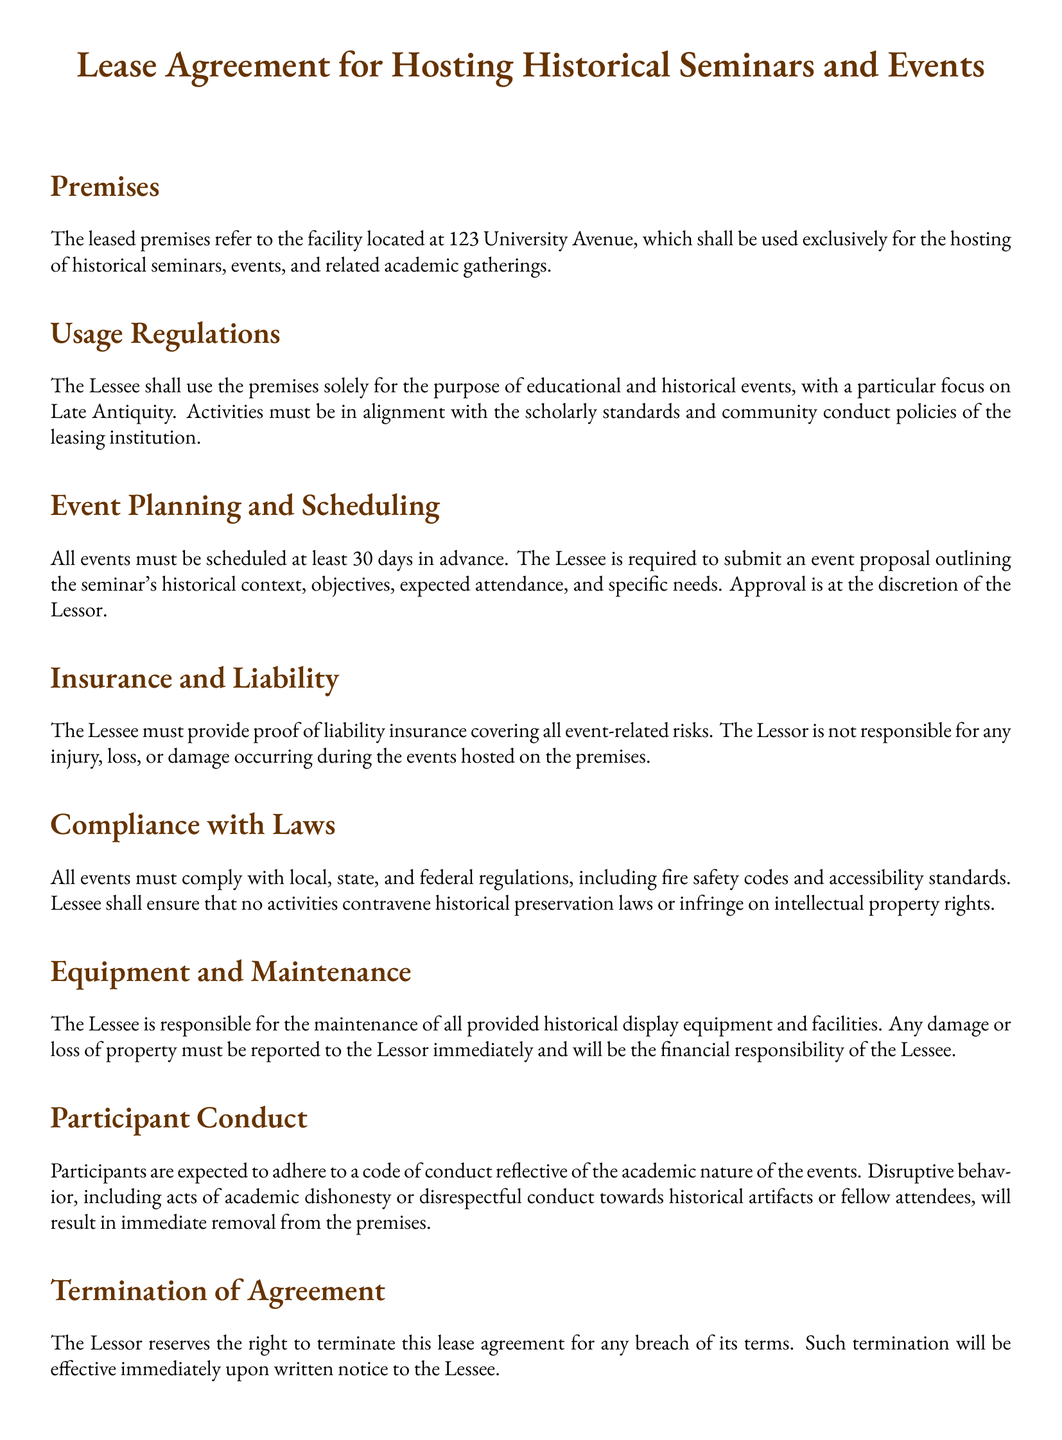What is the address of the leased premises? The address of the leased premises is mentioned in the document as "123 University Avenue."
Answer: 123 University Avenue How many days in advance must events be scheduled? The document specifies that all events must be scheduled at least "30 days in advance."
Answer: 30 days What is the focus of the events to be hosted? The document indicates that the events should have a particular focus on "Late Antiquity."
Answer: Late Antiquity Who is responsible for maintaining the historical display equipment? The document states that "The Lessee is responsible for the maintenance" of the equipment.
Answer: Lessee What may happen upon a breach of the agreement? The document outlines that the "Lessor reserves the right to terminate this lease agreement" for any breach.
Answer: Terminate What type of insurance must the Lessee provide? According to the document, the Lessee must provide "proof of liability insurance" for event-related risks.
Answer: Liability insurance What conduct is expected from participants? The document expects participants to adhere to a "code of conduct reflective of the academic nature" of the events.
Answer: Code of conduct What is the result of disruptive behavior during events? The document states that such behavior will result in "immediate removal from the premises."
Answer: Immediate removal 